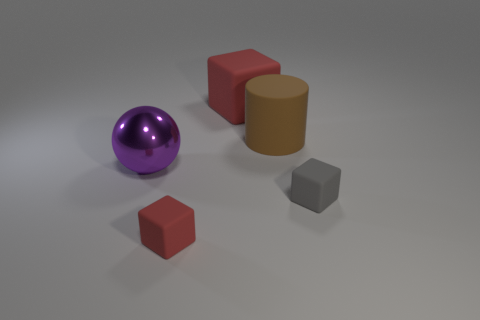How many tiny objects are either purple spheres or red blocks?
Give a very brief answer. 1. Are there any large green objects?
Provide a short and direct response. No. What is the size of the gray block that is made of the same material as the large cylinder?
Ensure brevity in your answer.  Small. Do the small red cube and the large red block have the same material?
Provide a short and direct response. Yes. How many other objects are the same material as the brown object?
Give a very brief answer. 3. What number of large objects are left of the large brown rubber cylinder and behind the purple metal ball?
Provide a short and direct response. 1. The big cylinder has what color?
Your answer should be compact. Brown. What material is the gray object that is the same shape as the big red matte thing?
Offer a very short reply. Rubber. Are there any other things that are the same material as the tiny gray object?
Your answer should be compact. Yes. Is the big cube the same color as the metallic ball?
Offer a terse response. No. 